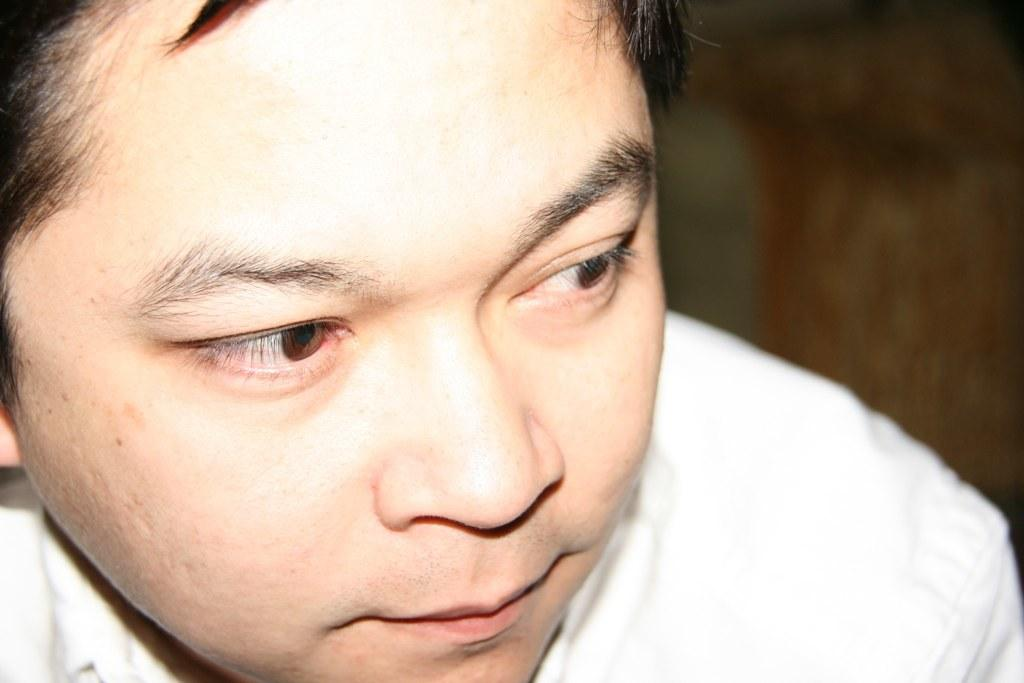What is the main subject of the image? There is a person's face in the image. What type of wood is used to make the person's clothing in the image? There is no wood or clothing present in the image, as it only features a person's face. 